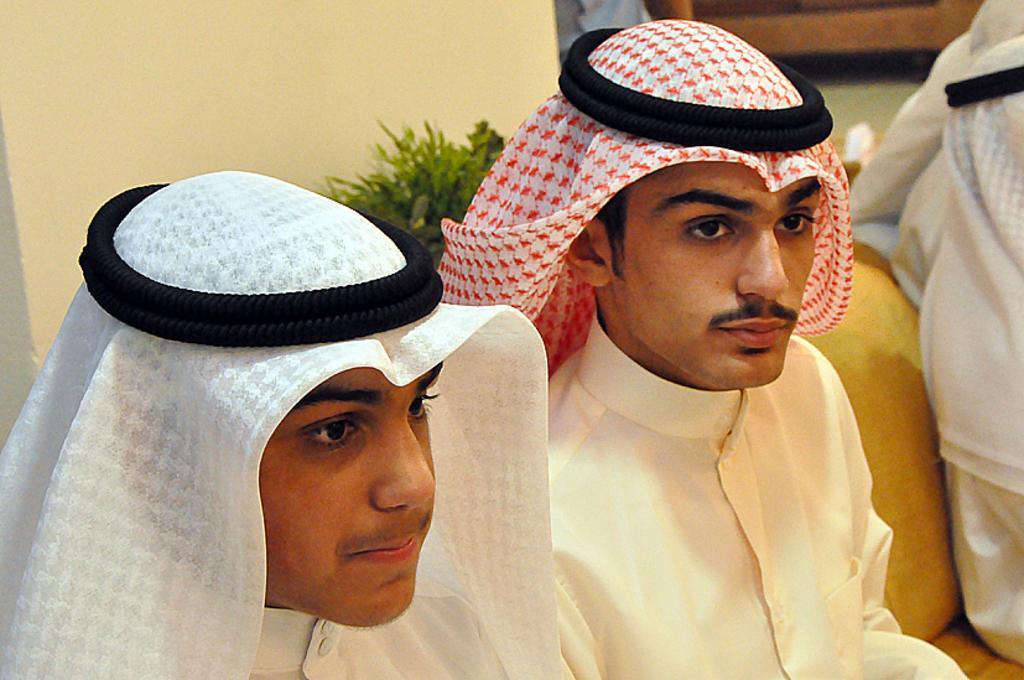How would you summarize this image in a sentence or two? In this image I can see two men are wearing white color dresses, headgear and sitting on a couch. On the right side, I can see another person is wearing white color dress. At the back of these people I can see a plant and wall. On the right top of the image there is a bench and also I can see a person. 